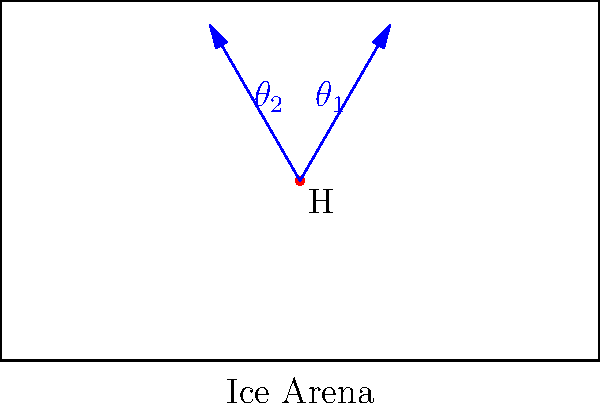In an ice arena, a VR headset is positioned at point H. The optimal viewing angle range for the headset is between $\theta_1$ and $\theta_2$, as shown in the diagram. If the total viewing angle $\theta_2 - \theta_1 = 60°$, and the bisector of this angle is perpendicular to the long side of the arena, calculate the value of $\theta_1$. To solve this problem, let's follow these steps:

1) First, we need to understand that the bisector of the viewing angle is perpendicular to the long side of the arena. This means it forms a 90° angle with the bottom of the arena.

2) Let's call the angle between the bisector and $\theta_1$ as $x$. Then, the angle between the bisector and $\theta_2$ will also be $x$.

3) We know that $\theta_2 - \theta_1 = 60°$. This means:

   $2x = 60°$
   $x = 30°$

4) Now, we need to find $\theta_1$. We know that $\theta_1$ plus the angle between $\theta_1$ and the perpendicular bisector should equal 90°:

   $\theta_1 + x = 90°$

5) Substituting the value of $x$:

   $\theta_1 + 30° = 90°$
   $\theta_1 = 90° - 30° = 60°$

Therefore, the value of $\theta_1$ is 60°.
Answer: $60°$ 